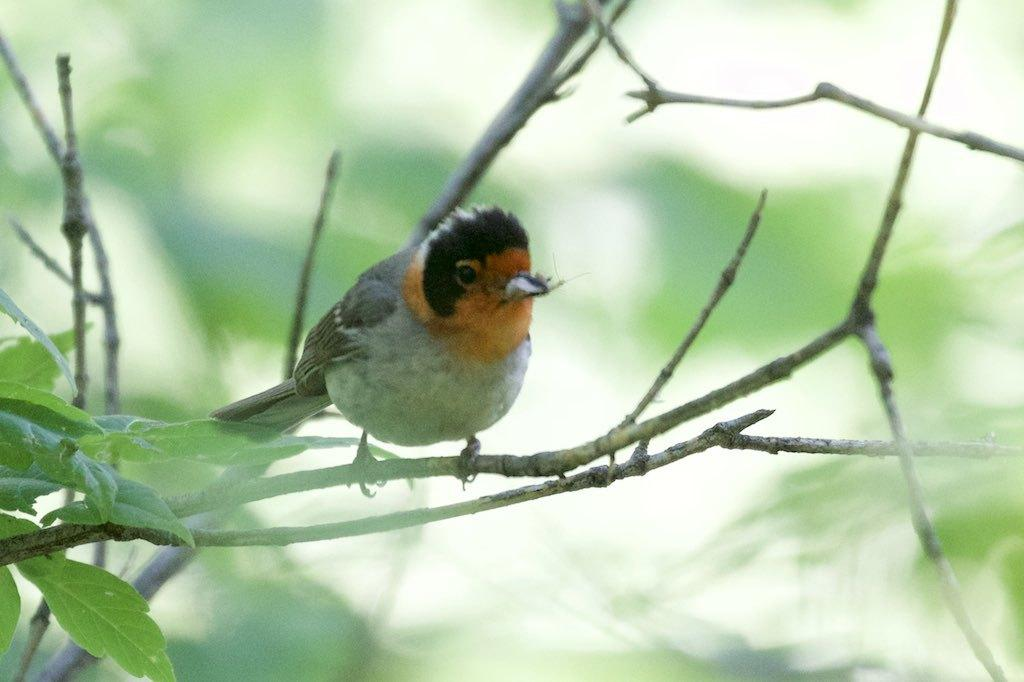What type of animal is in the image? There is a bird in the image. Where is the bird located? The bird is on a stem. What can be seen on the left side of the image? There are leaves and stems on the left side of the image. How would you describe the background of the image? The background of the image is blurry. What type of banana offer can be seen in the image? There is no banana or offer present in the image; it features a bird on a stem with leaves and stems in the background. 